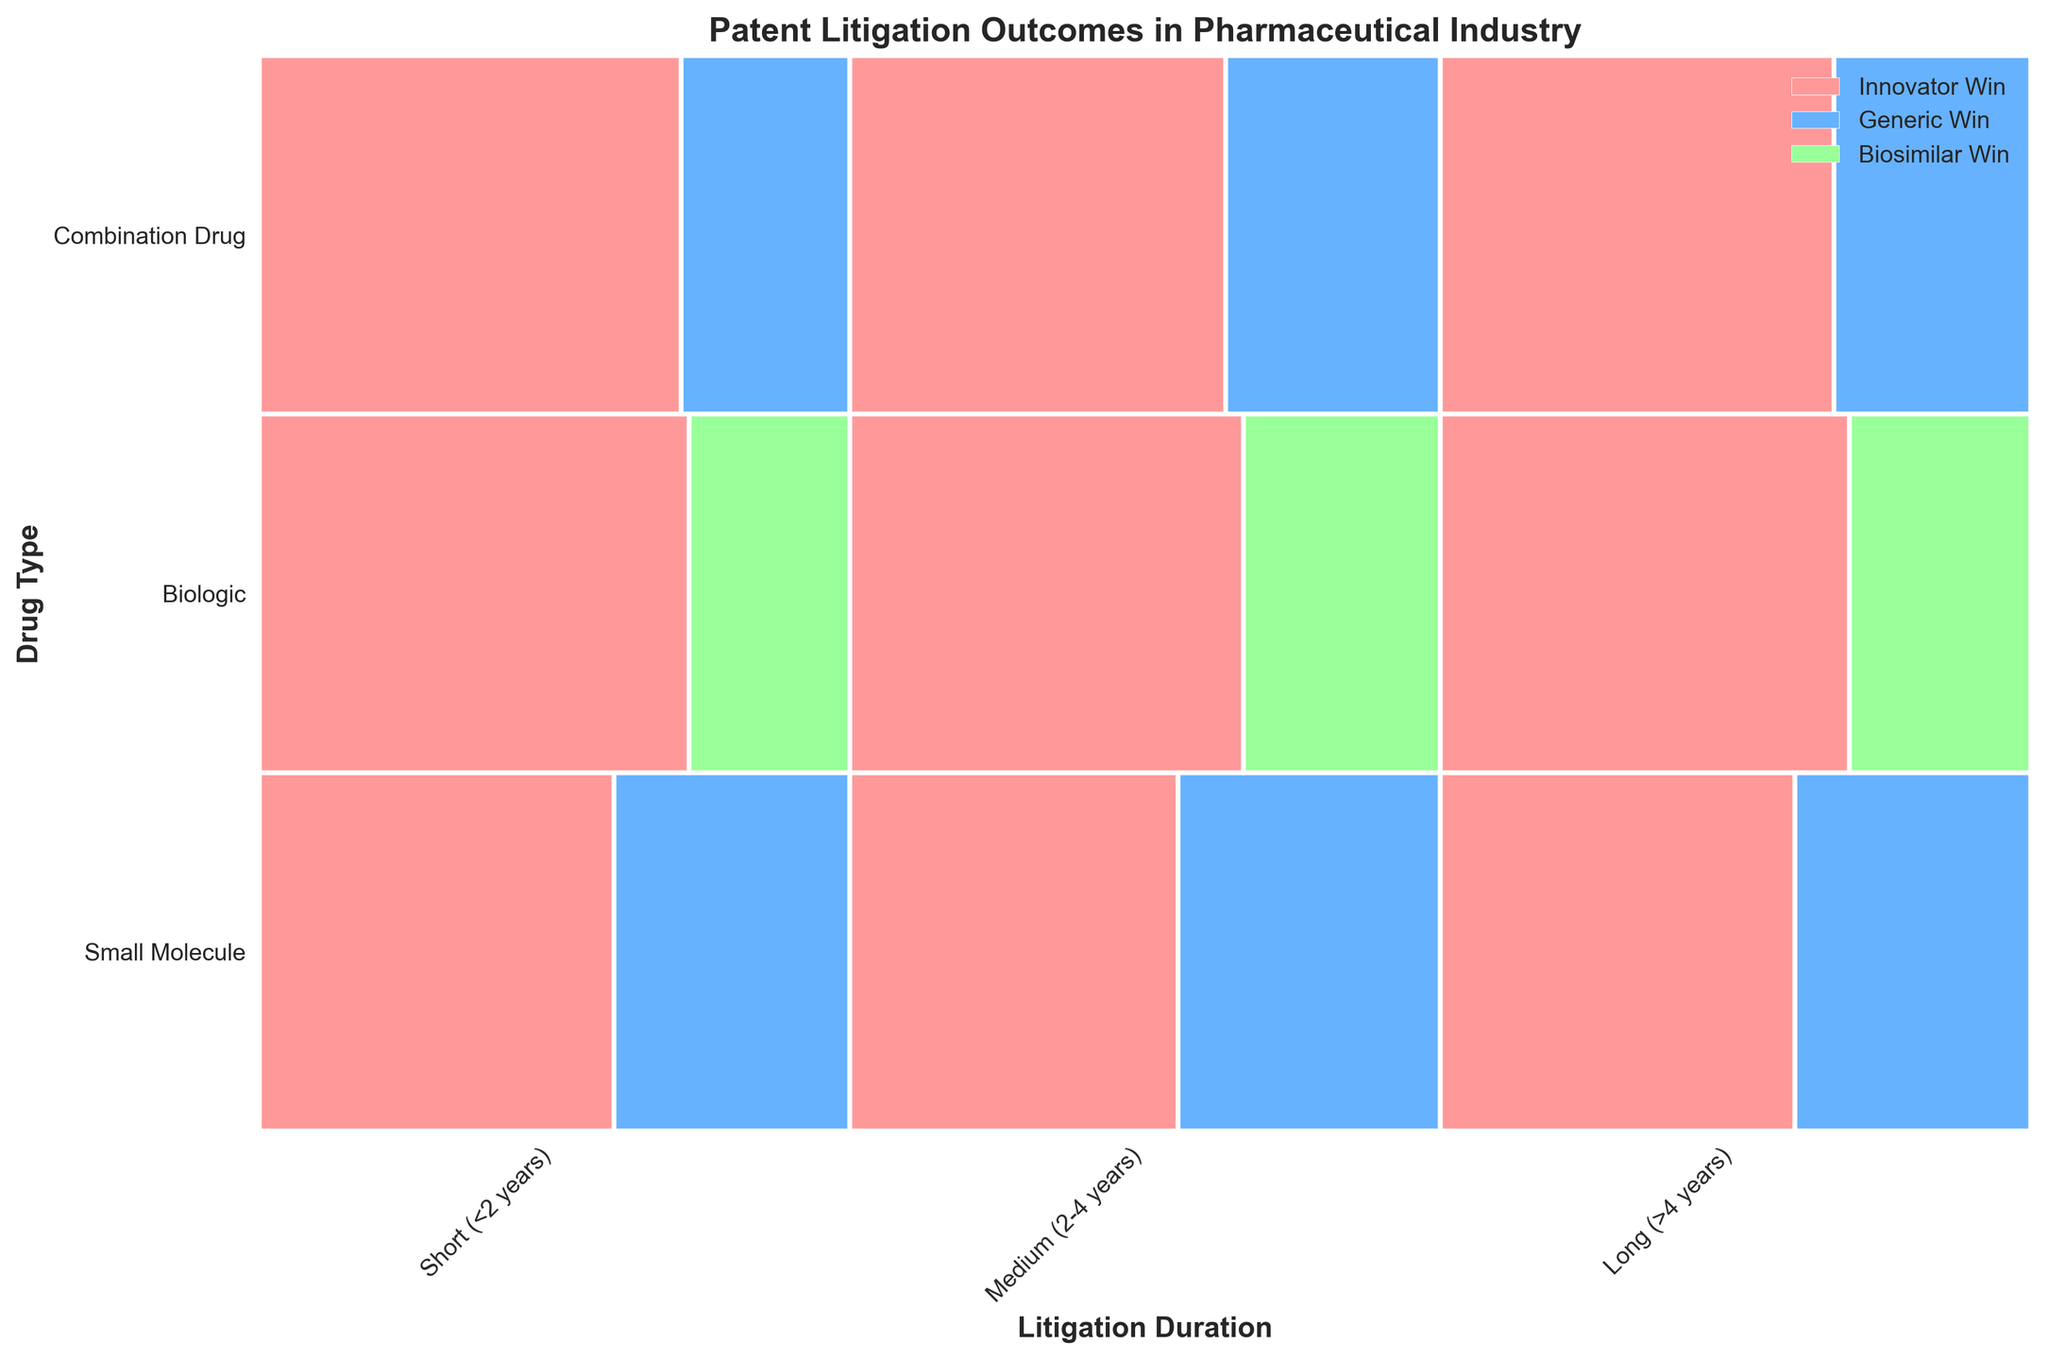What is the title of the figure? The title is prominently displayed at the top of the figure. It provides an overview of what information is being presented in the plot.
Answer: "Patent Litigation Outcomes in Pharmaceutical Industry" What are the labels for the x-axis and y-axis? The labels are located along the respective axes and help identify what each axis represents. The x-axis represents the litigation duration, and the y-axis represents the drug type.
Answer: x-axis: Litigation Duration, y-axis: Drug Type How do the outcomes for Biologic drugs in medium-duration litigation compare? Compare the proportions of Innovator Win and Biosimilar Win for Biologic drugs in medium (2-4 years) litigation duration. Identify the segment sizes for each outcome within the given drug type and litigation duration.
Answer: Innovator Win is larger than Biosimilar Win What are the possible outcomes for Combination drugs in short-duration litigation? Look at the sections corresponding to Combination drugs in short (<2 years) litigation duration and identify the labeled outcomes.
Answer: Innovator Win, Generic Win Which drug type has the smallest proportion of Innovator Win in long-duration litigation? Examine the proportion sizes for Innovator Win within each drug type for long (>4 years) litigation duration and identify the smallest one.
Answer: Combination Drug What is the proportion of Generic Win in medium-duration litigation for Small Molecule drugs? Look at the section for Small Molecule drugs in medium (2-4 years) litigation duration and calculate the proportion size for Generic Win among the total outcomes.
Answer: 20/(25+20) = 0.44 (or 44%) Which litigation duration has the highest proportion of Innovator Win for Small Molecule drugs? Compare the proportions of Innovator Win within each litigation duration class for Small Molecule drugs and identify the highest one.
Answer: Medium (2-4 years) How does the proportion of Innovator Win change for Biologic drugs from short to long-duration litigations? Observe the changes in the segment size of Innovator Win for Biologic drugs across short (<2 years), medium (2-4 years), and long (>4 years) litigations and describe the pattern.
Answer: Increases from short to medium, then slightly decreases in long Which outcome and litigation duration combination is least frequent for Biologic drugs? Look at the sections for each outcome within the durations for Biologic drugs and identify the smallest section.
Answer: Biosimilar Win in short (<2 years) How many different drug types are represented in the plot? Identify the number of unique drug type labels along the y-axis.
Answer: 3 